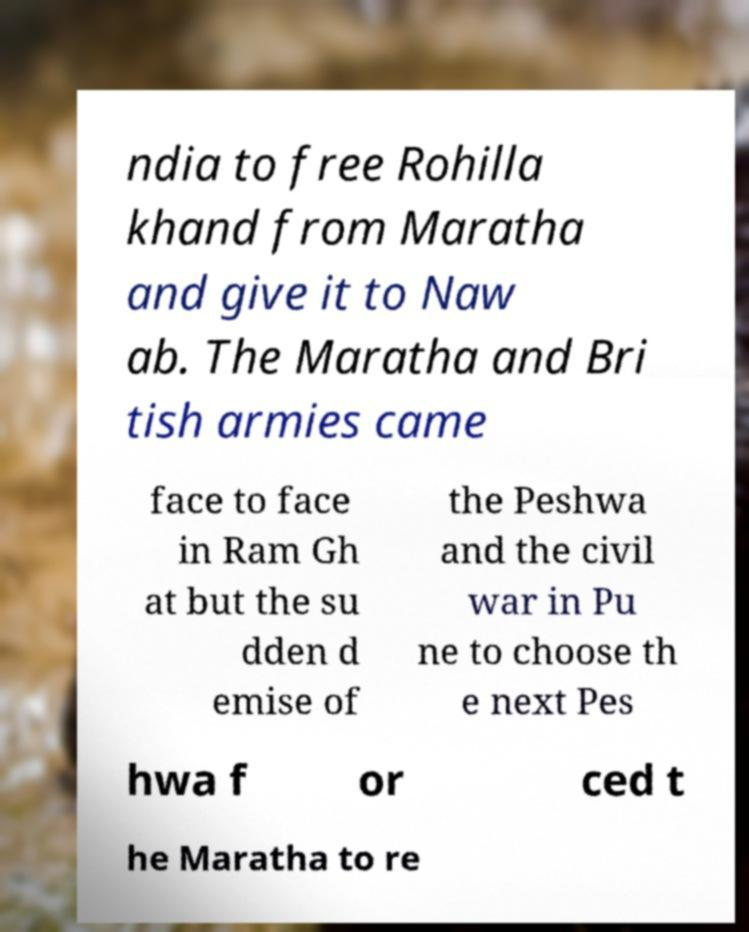Please identify and transcribe the text found in this image. ndia to free Rohilla khand from Maratha and give it to Naw ab. The Maratha and Bri tish armies came face to face in Ram Gh at but the su dden d emise of the Peshwa and the civil war in Pu ne to choose th e next Pes hwa f or ced t he Maratha to re 